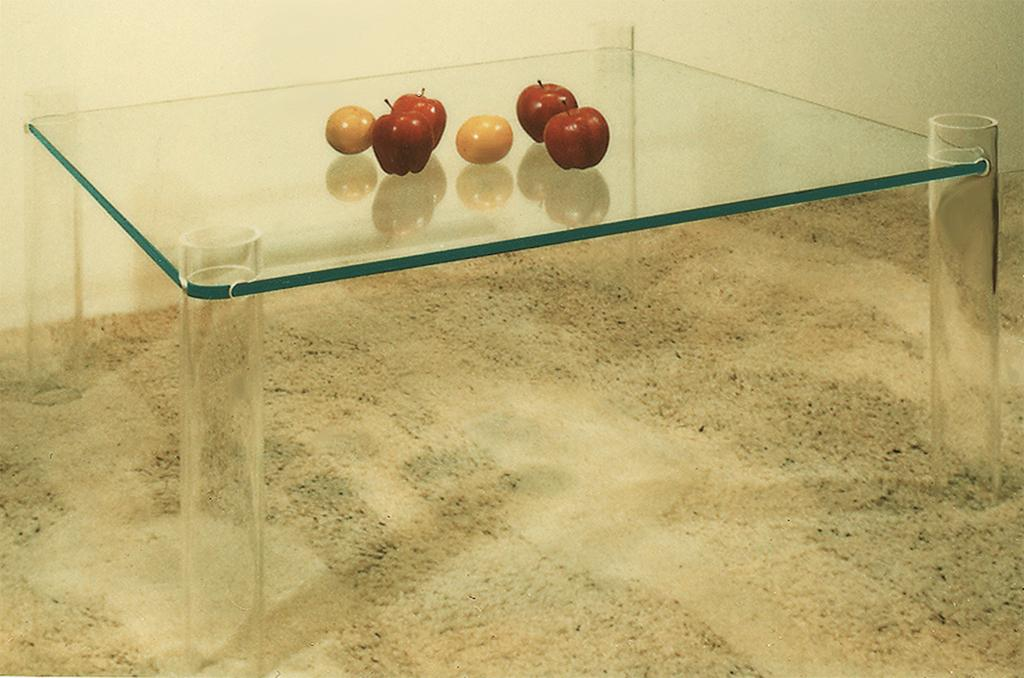What type of food can be seen in the image? There are apples in the image. Are there any other types of food in the image besides apples? Yes, there are other fruits in the image. Where are the fruits located in the image? The fruits are on a table. What is the value of the apples in the image? The value of the apples cannot be determined from the image alone, as it depends on factors such as their quality, size, and market prices. 